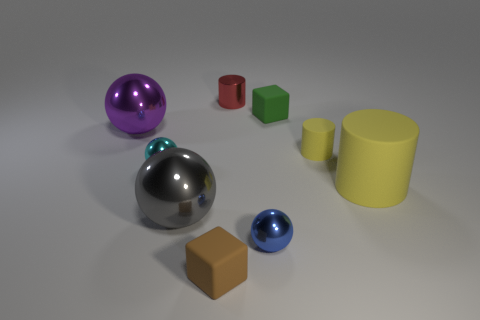Add 1 big gray metal things. How many objects exist? 10 Subtract all small red metallic cylinders. How many cylinders are left? 2 Subtract all gray spheres. How many spheres are left? 3 Add 9 gray spheres. How many gray spheres exist? 10 Subtract 0 yellow balls. How many objects are left? 9 Subtract all balls. How many objects are left? 5 Subtract 2 blocks. How many blocks are left? 0 Subtract all cyan cubes. Subtract all brown cylinders. How many cubes are left? 2 Subtract all gray balls. How many yellow cylinders are left? 2 Subtract all red blocks. Subtract all small metal things. How many objects are left? 6 